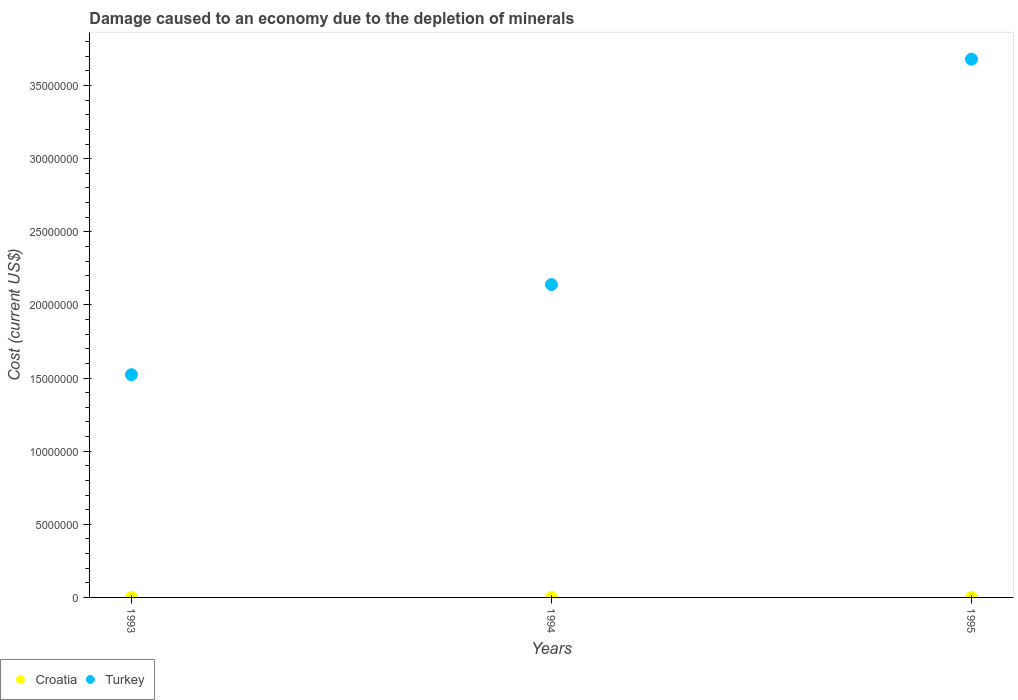How many different coloured dotlines are there?
Offer a terse response. 2. What is the cost of damage caused due to the depletion of minerals in Croatia in 1993?
Your answer should be very brief. 1.29e+04. Across all years, what is the maximum cost of damage caused due to the depletion of minerals in Turkey?
Your response must be concise. 3.68e+07. Across all years, what is the minimum cost of damage caused due to the depletion of minerals in Croatia?
Make the answer very short. 3807.4. In which year was the cost of damage caused due to the depletion of minerals in Turkey maximum?
Ensure brevity in your answer.  1995. In which year was the cost of damage caused due to the depletion of minerals in Turkey minimum?
Provide a short and direct response. 1993. What is the total cost of damage caused due to the depletion of minerals in Turkey in the graph?
Your response must be concise. 7.34e+07. What is the difference between the cost of damage caused due to the depletion of minerals in Turkey in 1993 and that in 1995?
Provide a short and direct response. -2.16e+07. What is the difference between the cost of damage caused due to the depletion of minerals in Croatia in 1994 and the cost of damage caused due to the depletion of minerals in Turkey in 1995?
Give a very brief answer. -3.68e+07. What is the average cost of damage caused due to the depletion of minerals in Turkey per year?
Your answer should be compact. 2.45e+07. In the year 1995, what is the difference between the cost of damage caused due to the depletion of minerals in Turkey and cost of damage caused due to the depletion of minerals in Croatia?
Ensure brevity in your answer.  3.68e+07. What is the ratio of the cost of damage caused due to the depletion of minerals in Turkey in 1993 to that in 1995?
Give a very brief answer. 0.41. Is the cost of damage caused due to the depletion of minerals in Croatia in 1993 less than that in 1994?
Provide a succinct answer. No. Is the difference between the cost of damage caused due to the depletion of minerals in Turkey in 1994 and 1995 greater than the difference between the cost of damage caused due to the depletion of minerals in Croatia in 1994 and 1995?
Make the answer very short. No. What is the difference between the highest and the second highest cost of damage caused due to the depletion of minerals in Croatia?
Your answer should be compact. 3359.18. What is the difference between the highest and the lowest cost of damage caused due to the depletion of minerals in Croatia?
Offer a very short reply. 9078.26. In how many years, is the cost of damage caused due to the depletion of minerals in Turkey greater than the average cost of damage caused due to the depletion of minerals in Turkey taken over all years?
Your response must be concise. 1. Is the sum of the cost of damage caused due to the depletion of minerals in Croatia in 1993 and 1995 greater than the maximum cost of damage caused due to the depletion of minerals in Turkey across all years?
Offer a very short reply. No. Does the cost of damage caused due to the depletion of minerals in Turkey monotonically increase over the years?
Provide a succinct answer. Yes. Is the cost of damage caused due to the depletion of minerals in Turkey strictly less than the cost of damage caused due to the depletion of minerals in Croatia over the years?
Your answer should be compact. No. How many dotlines are there?
Your response must be concise. 2. How many years are there in the graph?
Keep it short and to the point. 3. Does the graph contain any zero values?
Give a very brief answer. No. Where does the legend appear in the graph?
Keep it short and to the point. Bottom left. What is the title of the graph?
Your answer should be very brief. Damage caused to an economy due to the depletion of minerals. Does "Pacific island small states" appear as one of the legend labels in the graph?
Offer a very short reply. No. What is the label or title of the Y-axis?
Provide a succinct answer. Cost (current US$). What is the Cost (current US$) of Croatia in 1993?
Provide a short and direct response. 1.29e+04. What is the Cost (current US$) of Turkey in 1993?
Make the answer very short. 1.52e+07. What is the Cost (current US$) in Croatia in 1994?
Your answer should be compact. 9526.47. What is the Cost (current US$) in Turkey in 1994?
Your response must be concise. 2.14e+07. What is the Cost (current US$) in Croatia in 1995?
Your answer should be very brief. 3807.4. What is the Cost (current US$) of Turkey in 1995?
Your answer should be compact. 3.68e+07. Across all years, what is the maximum Cost (current US$) in Croatia?
Give a very brief answer. 1.29e+04. Across all years, what is the maximum Cost (current US$) of Turkey?
Offer a terse response. 3.68e+07. Across all years, what is the minimum Cost (current US$) of Croatia?
Make the answer very short. 3807.4. Across all years, what is the minimum Cost (current US$) in Turkey?
Your response must be concise. 1.52e+07. What is the total Cost (current US$) of Croatia in the graph?
Give a very brief answer. 2.62e+04. What is the total Cost (current US$) in Turkey in the graph?
Your response must be concise. 7.34e+07. What is the difference between the Cost (current US$) of Croatia in 1993 and that in 1994?
Ensure brevity in your answer.  3359.18. What is the difference between the Cost (current US$) of Turkey in 1993 and that in 1994?
Your answer should be very brief. -6.16e+06. What is the difference between the Cost (current US$) of Croatia in 1993 and that in 1995?
Provide a short and direct response. 9078.26. What is the difference between the Cost (current US$) in Turkey in 1993 and that in 1995?
Provide a succinct answer. -2.16e+07. What is the difference between the Cost (current US$) in Croatia in 1994 and that in 1995?
Keep it short and to the point. 5719.07. What is the difference between the Cost (current US$) in Turkey in 1994 and that in 1995?
Offer a very short reply. -1.54e+07. What is the difference between the Cost (current US$) of Croatia in 1993 and the Cost (current US$) of Turkey in 1994?
Ensure brevity in your answer.  -2.14e+07. What is the difference between the Cost (current US$) in Croatia in 1993 and the Cost (current US$) in Turkey in 1995?
Your response must be concise. -3.68e+07. What is the difference between the Cost (current US$) in Croatia in 1994 and the Cost (current US$) in Turkey in 1995?
Ensure brevity in your answer.  -3.68e+07. What is the average Cost (current US$) in Croatia per year?
Make the answer very short. 8739.84. What is the average Cost (current US$) in Turkey per year?
Ensure brevity in your answer.  2.45e+07. In the year 1993, what is the difference between the Cost (current US$) in Croatia and Cost (current US$) in Turkey?
Ensure brevity in your answer.  -1.52e+07. In the year 1994, what is the difference between the Cost (current US$) in Croatia and Cost (current US$) in Turkey?
Keep it short and to the point. -2.14e+07. In the year 1995, what is the difference between the Cost (current US$) in Croatia and Cost (current US$) in Turkey?
Give a very brief answer. -3.68e+07. What is the ratio of the Cost (current US$) in Croatia in 1993 to that in 1994?
Your response must be concise. 1.35. What is the ratio of the Cost (current US$) of Turkey in 1993 to that in 1994?
Your answer should be compact. 0.71. What is the ratio of the Cost (current US$) in Croatia in 1993 to that in 1995?
Offer a terse response. 3.38. What is the ratio of the Cost (current US$) in Turkey in 1993 to that in 1995?
Provide a short and direct response. 0.41. What is the ratio of the Cost (current US$) of Croatia in 1994 to that in 1995?
Your answer should be very brief. 2.5. What is the ratio of the Cost (current US$) of Turkey in 1994 to that in 1995?
Offer a very short reply. 0.58. What is the difference between the highest and the second highest Cost (current US$) of Croatia?
Your answer should be very brief. 3359.18. What is the difference between the highest and the second highest Cost (current US$) in Turkey?
Give a very brief answer. 1.54e+07. What is the difference between the highest and the lowest Cost (current US$) in Croatia?
Offer a terse response. 9078.26. What is the difference between the highest and the lowest Cost (current US$) in Turkey?
Offer a very short reply. 2.16e+07. 